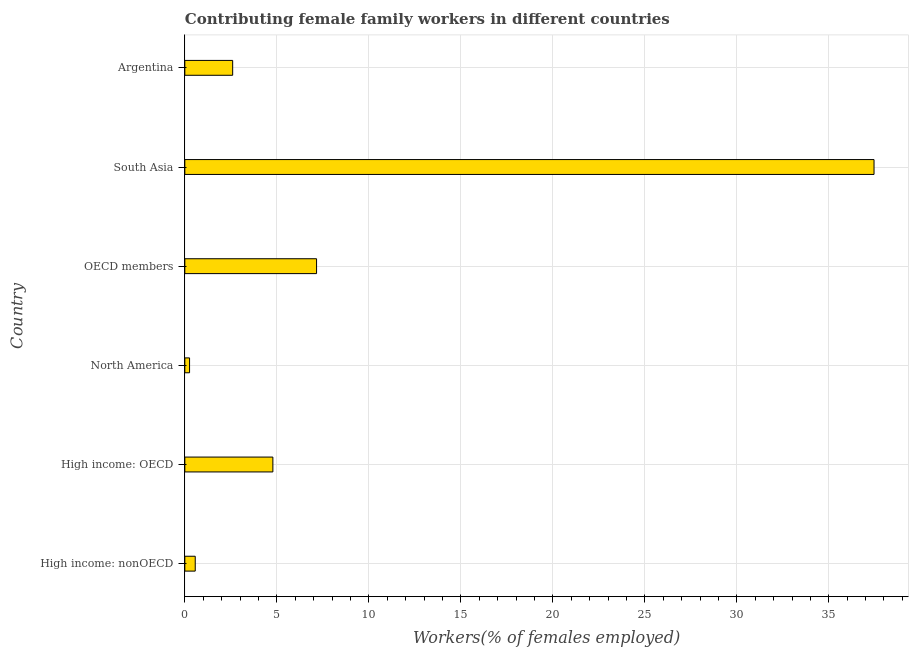Does the graph contain grids?
Your answer should be very brief. Yes. What is the title of the graph?
Provide a succinct answer. Contributing female family workers in different countries. What is the label or title of the X-axis?
Ensure brevity in your answer.  Workers(% of females employed). What is the label or title of the Y-axis?
Your answer should be very brief. Country. What is the contributing female family workers in North America?
Offer a terse response. 0.26. Across all countries, what is the maximum contributing female family workers?
Ensure brevity in your answer.  37.46. Across all countries, what is the minimum contributing female family workers?
Provide a short and direct response. 0.26. In which country was the contributing female family workers minimum?
Offer a very short reply. North America. What is the sum of the contributing female family workers?
Give a very brief answer. 52.83. What is the difference between the contributing female family workers in Argentina and High income: OECD?
Keep it short and to the point. -2.19. What is the average contributing female family workers per country?
Ensure brevity in your answer.  8.8. What is the median contributing female family workers?
Offer a very short reply. 3.69. In how many countries, is the contributing female family workers greater than 38 %?
Keep it short and to the point. 0. What is the ratio of the contributing female family workers in High income: OECD to that in South Asia?
Your answer should be compact. 0.13. Is the contributing female family workers in Argentina less than that in OECD members?
Your response must be concise. Yes. What is the difference between the highest and the second highest contributing female family workers?
Your answer should be very brief. 30.3. What is the difference between the highest and the lowest contributing female family workers?
Make the answer very short. 37.2. In how many countries, is the contributing female family workers greater than the average contributing female family workers taken over all countries?
Provide a succinct answer. 1. How many countries are there in the graph?
Ensure brevity in your answer.  6. What is the difference between two consecutive major ticks on the X-axis?
Make the answer very short. 5. What is the Workers(% of females employed) in High income: nonOECD?
Provide a short and direct response. 0.57. What is the Workers(% of females employed) in High income: OECD?
Your response must be concise. 4.79. What is the Workers(% of females employed) in North America?
Offer a very short reply. 0.26. What is the Workers(% of females employed) in OECD members?
Ensure brevity in your answer.  7.16. What is the Workers(% of females employed) of South Asia?
Your response must be concise. 37.46. What is the Workers(% of females employed) in Argentina?
Your response must be concise. 2.6. What is the difference between the Workers(% of females employed) in High income: nonOECD and High income: OECD?
Ensure brevity in your answer.  -4.22. What is the difference between the Workers(% of females employed) in High income: nonOECD and North America?
Your response must be concise. 0.31. What is the difference between the Workers(% of females employed) in High income: nonOECD and OECD members?
Keep it short and to the point. -6.59. What is the difference between the Workers(% of females employed) in High income: nonOECD and South Asia?
Offer a very short reply. -36.89. What is the difference between the Workers(% of females employed) in High income: nonOECD and Argentina?
Your answer should be very brief. -2.03. What is the difference between the Workers(% of females employed) in High income: OECD and North America?
Your answer should be very brief. 4.53. What is the difference between the Workers(% of females employed) in High income: OECD and OECD members?
Give a very brief answer. -2.37. What is the difference between the Workers(% of females employed) in High income: OECD and South Asia?
Ensure brevity in your answer.  -32.67. What is the difference between the Workers(% of females employed) in High income: OECD and Argentina?
Your answer should be compact. 2.19. What is the difference between the Workers(% of females employed) in North America and OECD members?
Make the answer very short. -6.9. What is the difference between the Workers(% of females employed) in North America and South Asia?
Your answer should be compact. -37.2. What is the difference between the Workers(% of females employed) in North America and Argentina?
Give a very brief answer. -2.34. What is the difference between the Workers(% of females employed) in OECD members and South Asia?
Offer a terse response. -30.3. What is the difference between the Workers(% of females employed) in OECD members and Argentina?
Your answer should be very brief. 4.56. What is the difference between the Workers(% of females employed) in South Asia and Argentina?
Your answer should be very brief. 34.86. What is the ratio of the Workers(% of females employed) in High income: nonOECD to that in High income: OECD?
Provide a succinct answer. 0.12. What is the ratio of the Workers(% of females employed) in High income: nonOECD to that in North America?
Offer a terse response. 2.2. What is the ratio of the Workers(% of females employed) in High income: nonOECD to that in OECD members?
Your answer should be very brief. 0.08. What is the ratio of the Workers(% of females employed) in High income: nonOECD to that in South Asia?
Make the answer very short. 0.01. What is the ratio of the Workers(% of females employed) in High income: nonOECD to that in Argentina?
Give a very brief answer. 0.22. What is the ratio of the Workers(% of females employed) in High income: OECD to that in North America?
Offer a very short reply. 18.6. What is the ratio of the Workers(% of females employed) in High income: OECD to that in OECD members?
Offer a very short reply. 0.67. What is the ratio of the Workers(% of females employed) in High income: OECD to that in South Asia?
Offer a very short reply. 0.13. What is the ratio of the Workers(% of females employed) in High income: OECD to that in Argentina?
Provide a short and direct response. 1.84. What is the ratio of the Workers(% of females employed) in North America to that in OECD members?
Ensure brevity in your answer.  0.04. What is the ratio of the Workers(% of females employed) in North America to that in South Asia?
Give a very brief answer. 0.01. What is the ratio of the Workers(% of females employed) in North America to that in Argentina?
Provide a short and direct response. 0.1. What is the ratio of the Workers(% of females employed) in OECD members to that in South Asia?
Your answer should be very brief. 0.19. What is the ratio of the Workers(% of females employed) in OECD members to that in Argentina?
Provide a succinct answer. 2.75. What is the ratio of the Workers(% of females employed) in South Asia to that in Argentina?
Your answer should be very brief. 14.41. 